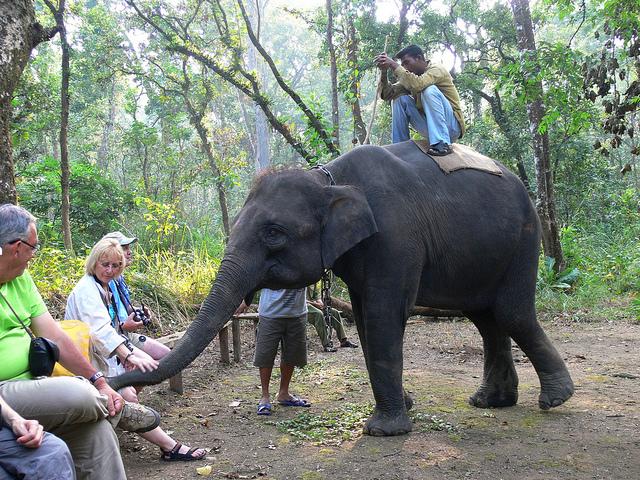What is the Elephant standing in?
Answer briefly. Dirt. What country might this be?
Keep it brief. Africa. What is on the back of the elephant?
Keep it brief. Man. Is the woman happy?
Answer briefly. Yes. What color is the woman's purse?
Be succinct. Black. Is the elephant looking at the woman?
Concise answer only. Yes. How many people are there?
Short answer required. 6. Does this elephant look young or old?
Answer briefly. Young. Does the elephant have tusks?
Short answer required. No. How many people are in front of the elephant?
Short answer required. 4. Is the person next to the lady holding food for the elephant?
Short answer required. No. What kind of hairstyle is the woman wearing?
Answer briefly. Short. Is the savanna?
Quick response, please. No. Where are the elephants going?
Keep it brief. Visiting. What are the white things on the elephant called?
Keep it brief. Tusks. What color is the baby elephant?
Give a very brief answer. Gray. Are any people here?
Give a very brief answer. Yes. Does the elephant have long tusks?
Quick response, please. No. What is the name of the white object attached to the elephant?
Keep it brief. Not possible. Is anyone currently riding the pachyderm?
Give a very brief answer. Yes. Is there a car in the picture?
Keep it brief. No. How many people are riding the elephant?
Be succinct. 1. How many women are here?
Short answer required. 1. Does the girl's head look off-center from the rest of her body?
Quick response, please. No. What color are the people's coats?
Be succinct. White. 